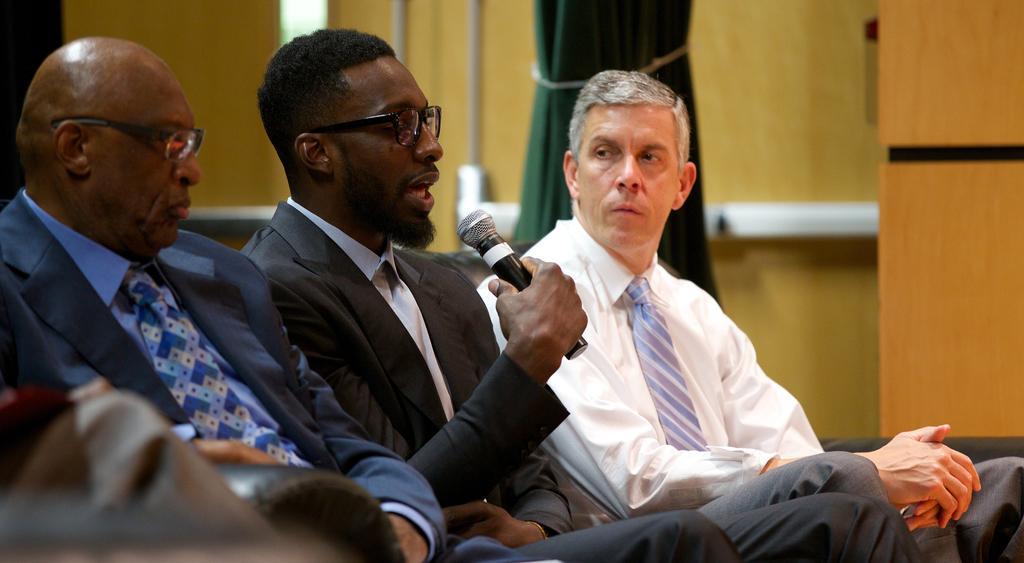Please provide a concise description of this image. In the foreground I can see three persons and a person is holding a mike in hand. In the background I can see a wall and a curtain. This image is taken in a hall. 